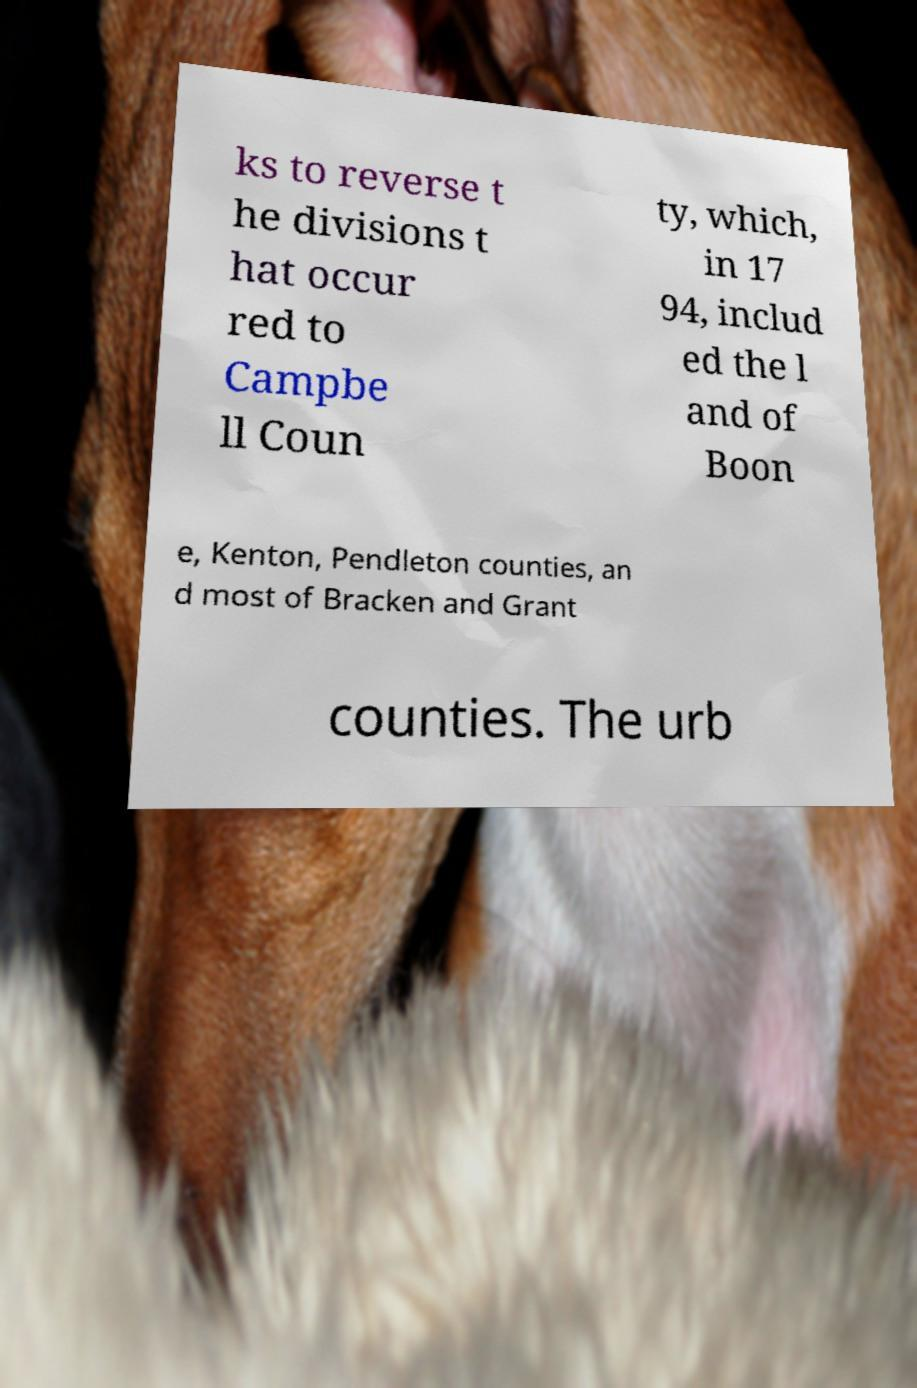Please identify and transcribe the text found in this image. ks to reverse t he divisions t hat occur red to Campbe ll Coun ty, which, in 17 94, includ ed the l and of Boon e, Kenton, Pendleton counties, an d most of Bracken and Grant counties. The urb 